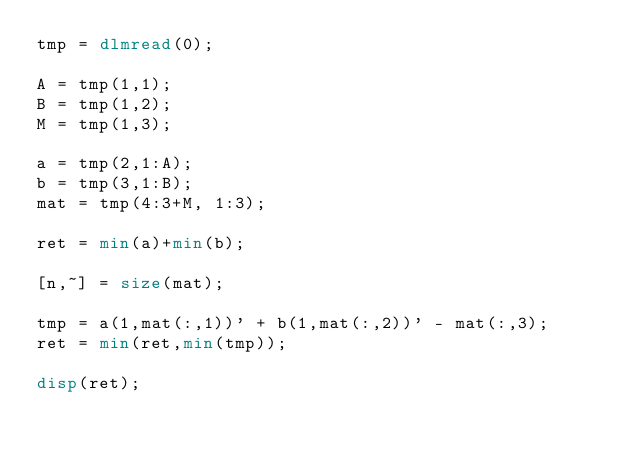Convert code to text. <code><loc_0><loc_0><loc_500><loc_500><_Octave_>tmp = dlmread(0);

A = tmp(1,1);
B = tmp(1,2);
M = tmp(1,3);

a = tmp(2,1:A);
b = tmp(3,1:B);
mat = tmp(4:3+M, 1:3);

ret = min(a)+min(b);

[n,~] = size(mat);

tmp = a(1,mat(:,1))' + b(1,mat(:,2))' - mat(:,3);
ret = min(ret,min(tmp));

disp(ret);

</code> 